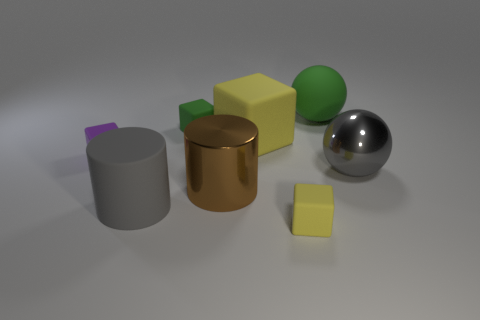What number of matte objects are small green spheres or small green objects?
Make the answer very short. 1. There is a small block that is the same color as the large rubber block; what is it made of?
Keep it short and to the point. Rubber. Does the brown cylinder have the same size as the green sphere?
Offer a very short reply. Yes. How many objects are tiny rubber cylinders or large gray objects in front of the brown cylinder?
Your answer should be compact. 1. There is a block that is the same size as the matte cylinder; what material is it?
Offer a very short reply. Rubber. What is the material of the tiny block that is both on the right side of the rubber cylinder and behind the brown metal object?
Provide a short and direct response. Rubber. There is a gray thing that is on the right side of the green ball; are there any yellow objects behind it?
Ensure brevity in your answer.  Yes. There is a matte thing that is both on the right side of the tiny green block and in front of the big gray metallic sphere; what size is it?
Make the answer very short. Small. What number of purple things are rubber spheres or rubber blocks?
Provide a short and direct response. 1. The green matte object that is the same size as the purple block is what shape?
Your answer should be very brief. Cube. 